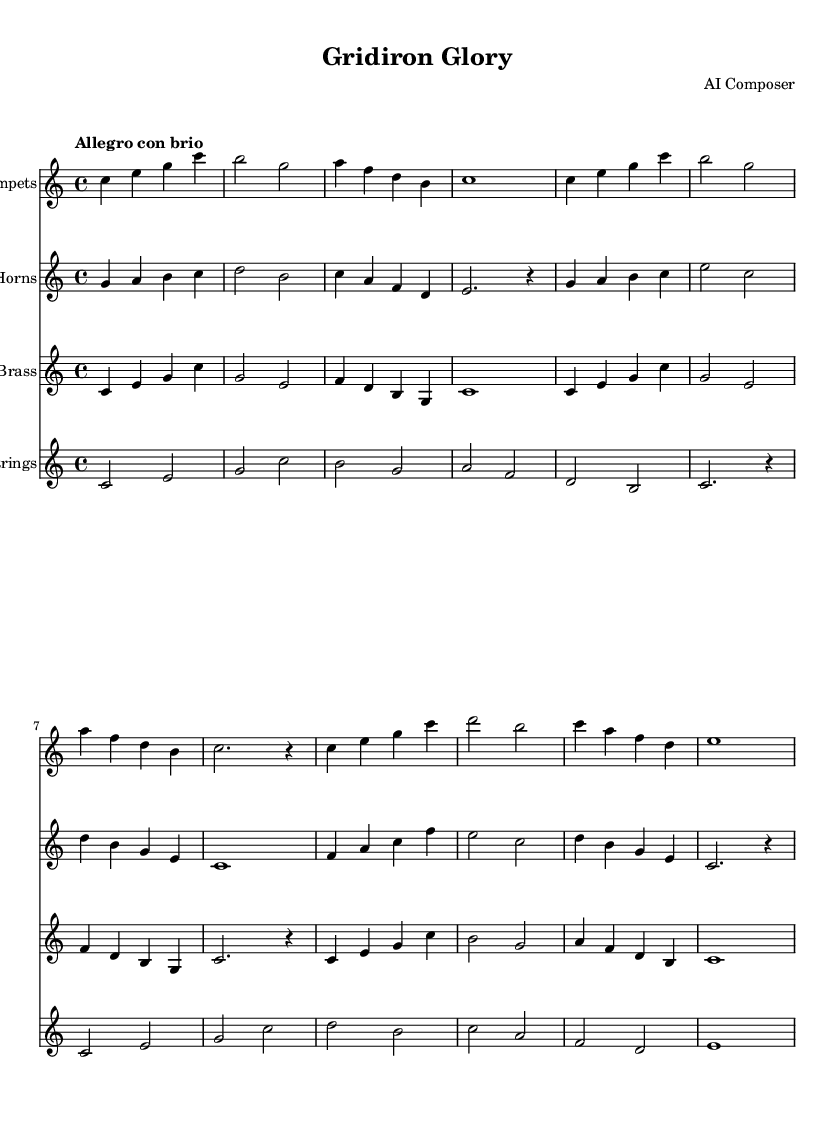What is the key signature of this music? The key signature is C major, which indicates that there are no sharps or flats in the piece. You can determine this by looking at the key signature symbol placed at the beginning of the staff.
Answer: C major What is the time signature of this music? The time signature is 4/4, which means there are four beats in each measure and a quarter note receives one beat. This is visible next to the clef at the start of the piece.
Answer: 4/4 What is the tempo marking of this music? The tempo marking is "Allegro con brio," indicating a lively and spirited pace. This is found at the beginning of the score.
Answer: Allegro con brio How many measures are in the first trumpet section? The first trumpet section has eight measures, each separated by bar lines. By counting the spaces between the bar lines in the first section of the trumpet staff, we arrive at this number.
Answer: 8 measures In which clef is the string section written? The string section is written in the treble clef, which is used for higher-pitched instruments. This can be identified by the clef symbol at the beginning of the staff for strings.
Answer: Treble clef What is the highest pitch written in the trumpets? The highest pitch written in the trumpets is a C note. You can find this by visually inspecting the notes on the staff and identifying the highest one played in the trumpet part.
Answer: C How does the dynamics vary throughout the piece? The dynamics vary between sections to create contrast, which is characteristic of heroic orchestral music. Notations such as crescendos or accents are used, though specific markings aren't given in the provided music details. This implies a build-up leading to more intense sections.
Answer: Varies throughout 